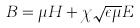<formula> <loc_0><loc_0><loc_500><loc_500>B = \mu H + \chi \sqrt { \epsilon \mu } E</formula> 